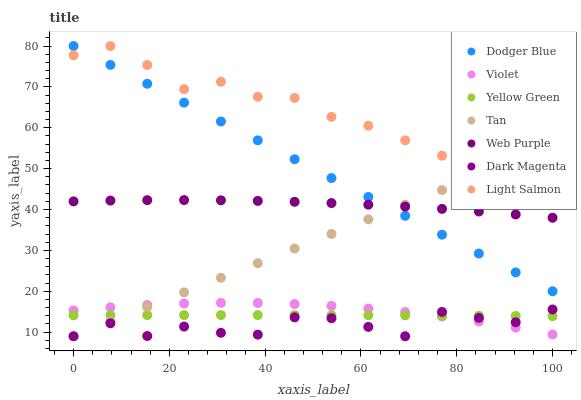Does Dark Magenta have the minimum area under the curve?
Answer yes or no. Yes. Does Light Salmon have the maximum area under the curve?
Answer yes or no. Yes. Does Yellow Green have the minimum area under the curve?
Answer yes or no. No. Does Yellow Green have the maximum area under the curve?
Answer yes or no. No. Is Tan the smoothest?
Answer yes or no. Yes. Is Dark Magenta the roughest?
Answer yes or no. Yes. Is Yellow Green the smoothest?
Answer yes or no. No. Is Yellow Green the roughest?
Answer yes or no. No. Does Tan have the lowest value?
Answer yes or no. Yes. Does Yellow Green have the lowest value?
Answer yes or no. No. Does Dodger Blue have the highest value?
Answer yes or no. Yes. Does Web Purple have the highest value?
Answer yes or no. No. Is Yellow Green less than Dodger Blue?
Answer yes or no. Yes. Is Dodger Blue greater than Yellow Green?
Answer yes or no. Yes. Does Dodger Blue intersect Web Purple?
Answer yes or no. Yes. Is Dodger Blue less than Web Purple?
Answer yes or no. No. Is Dodger Blue greater than Web Purple?
Answer yes or no. No. Does Yellow Green intersect Dodger Blue?
Answer yes or no. No. 